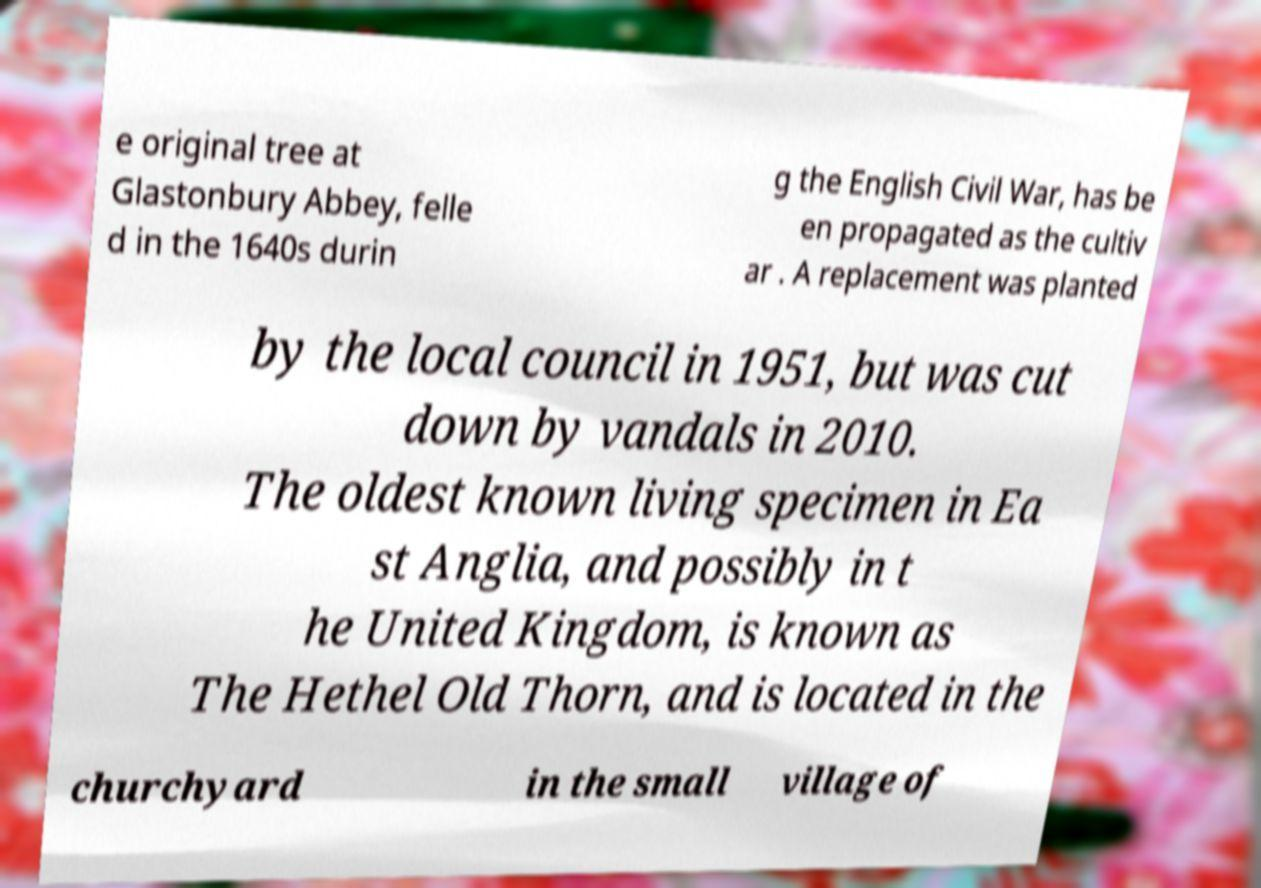There's text embedded in this image that I need extracted. Can you transcribe it verbatim? e original tree at Glastonbury Abbey, felle d in the 1640s durin g the English Civil War, has be en propagated as the cultiv ar . A replacement was planted by the local council in 1951, but was cut down by vandals in 2010. The oldest known living specimen in Ea st Anglia, and possibly in t he United Kingdom, is known as The Hethel Old Thorn, and is located in the churchyard in the small village of 